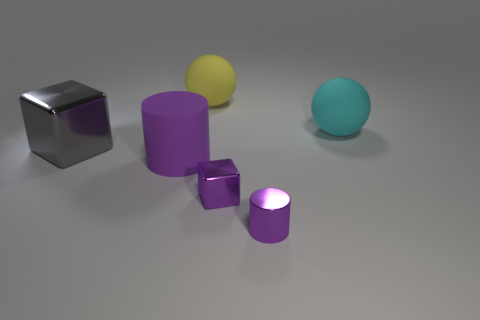Is the big sphere that is right of the tiny purple cylinder made of the same material as the block that is in front of the big purple thing?
Give a very brief answer. No. Is the number of gray metal blocks that are in front of the big purple matte cylinder less than the number of gray metallic blocks?
Your answer should be very brief. Yes. Are there any other things that have the same shape as the purple rubber object?
Your answer should be compact. Yes. What is the color of the tiny metal object that is the same shape as the big gray object?
Ensure brevity in your answer.  Purple. There is a rubber sphere that is on the left side of the cyan ball; does it have the same size as the purple metallic cylinder?
Offer a terse response. No. There is a block left of the metal block that is right of the big gray thing; how big is it?
Keep it short and to the point. Large. Does the big gray block have the same material as the large object behind the cyan thing?
Provide a short and direct response. No. Are there fewer gray metal blocks to the right of the cyan rubber sphere than big gray metal blocks that are to the left of the small metallic block?
Offer a terse response. Yes. There is a cube that is made of the same material as the big gray thing; what color is it?
Provide a short and direct response. Purple. Are there any big matte spheres that are to the left of the ball right of the yellow matte sphere?
Give a very brief answer. Yes. 